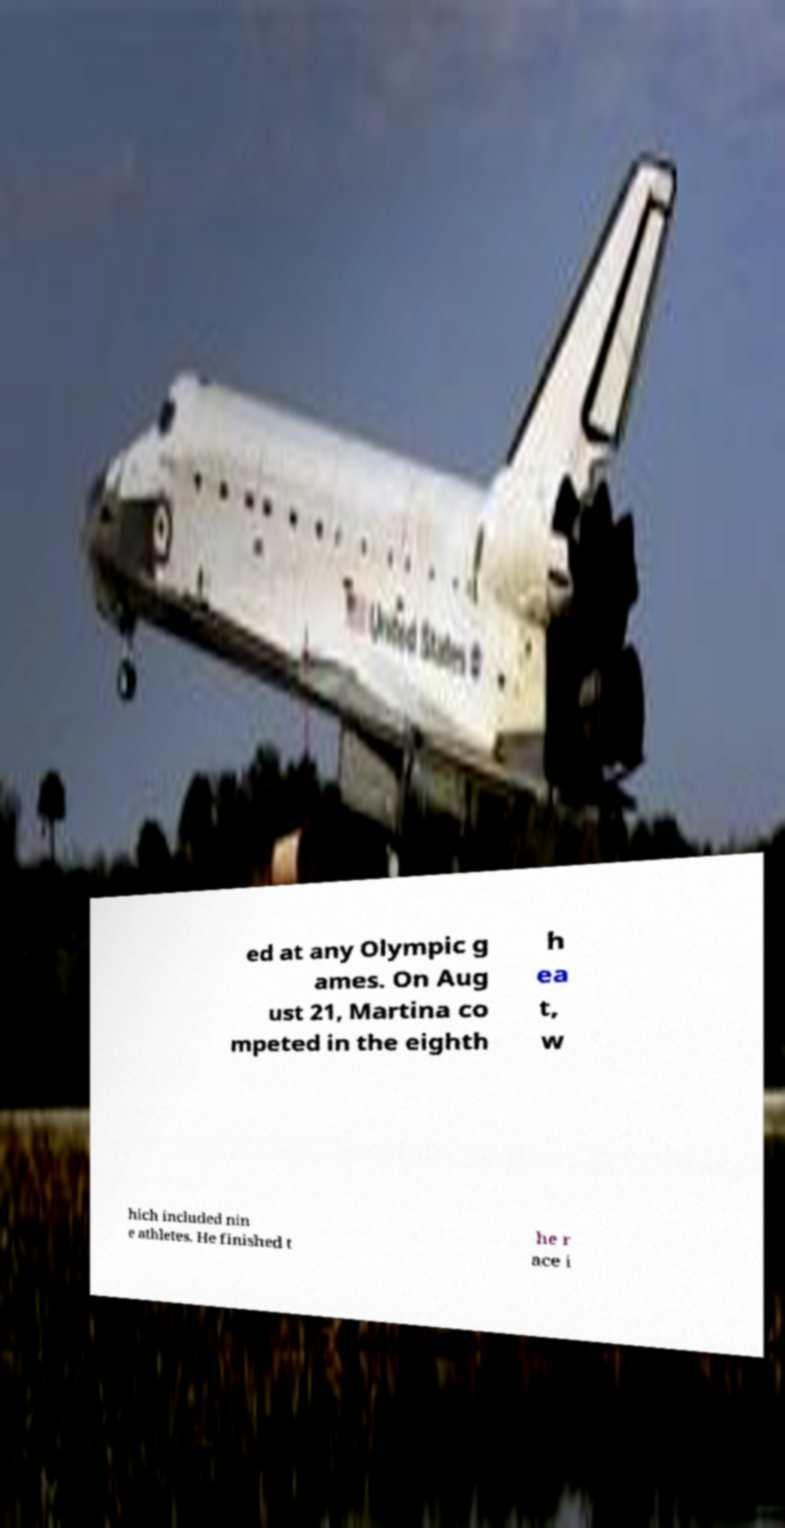Please read and relay the text visible in this image. What does it say? ed at any Olympic g ames. On Aug ust 21, Martina co mpeted in the eighth h ea t, w hich included nin e athletes. He finished t he r ace i 